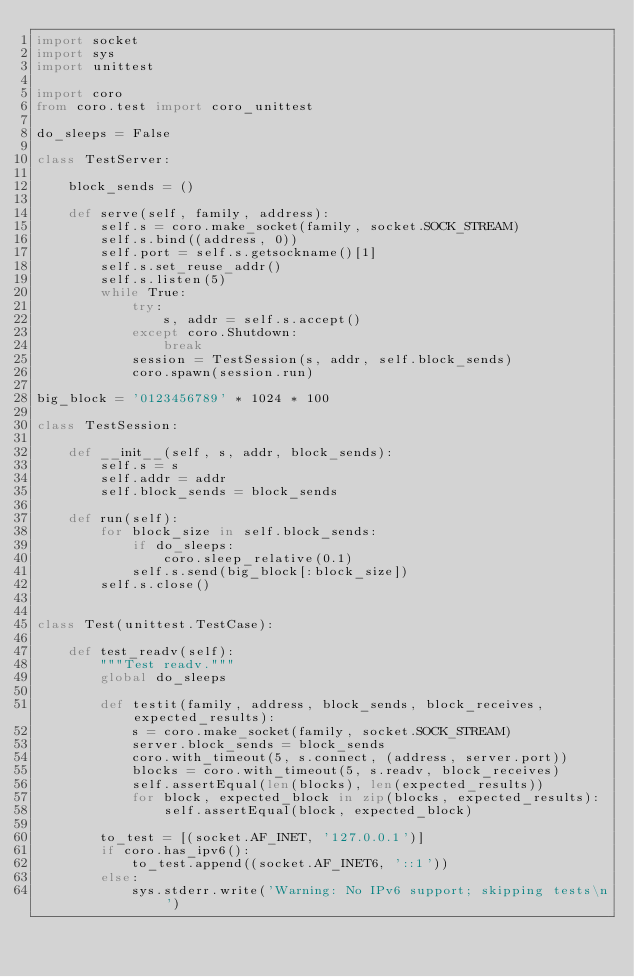Convert code to text. <code><loc_0><loc_0><loc_500><loc_500><_Python_>import socket
import sys
import unittest

import coro
from coro.test import coro_unittest

do_sleeps = False

class TestServer:

    block_sends = ()

    def serve(self, family, address):
        self.s = coro.make_socket(family, socket.SOCK_STREAM)
        self.s.bind((address, 0))
        self.port = self.s.getsockname()[1]
        self.s.set_reuse_addr()
        self.s.listen(5)
        while True:
            try:
                s, addr = self.s.accept()
            except coro.Shutdown:
                break
            session = TestSession(s, addr, self.block_sends)
            coro.spawn(session.run)

big_block = '0123456789' * 1024 * 100

class TestSession:

    def __init__(self, s, addr, block_sends):
        self.s = s
        self.addr = addr
        self.block_sends = block_sends

    def run(self):
        for block_size in self.block_sends:
            if do_sleeps:
                coro.sleep_relative(0.1)
            self.s.send(big_block[:block_size])
        self.s.close()


class Test(unittest.TestCase):

    def test_readv(self):
        """Test readv."""
        global do_sleeps

        def testit(family, address, block_sends, block_receives, expected_results):
            s = coro.make_socket(family, socket.SOCK_STREAM)
            server.block_sends = block_sends
            coro.with_timeout(5, s.connect, (address, server.port))
            blocks = coro.with_timeout(5, s.readv, block_receives)
            self.assertEqual(len(blocks), len(expected_results))
            for block, expected_block in zip(blocks, expected_results):
                self.assertEqual(block, expected_block)

        to_test = [(socket.AF_INET, '127.0.0.1')]
        if coro.has_ipv6():
            to_test.append((socket.AF_INET6, '::1'))
        else:
            sys.stderr.write('Warning: No IPv6 support; skipping tests\n')</code> 